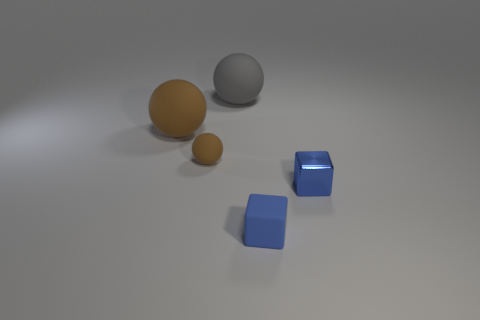Subtract all brown rubber balls. How many balls are left? 1 Subtract all brown balls. How many balls are left? 1 Add 5 large brown spheres. How many objects exist? 10 Subtract all spheres. How many objects are left? 2 Subtract 2 cubes. How many cubes are left? 0 Subtract all green spheres. Subtract all gray cylinders. How many spheres are left? 3 Subtract all gray blocks. How many brown balls are left? 2 Subtract all brown balls. Subtract all blue things. How many objects are left? 1 Add 5 balls. How many balls are left? 8 Add 1 small blocks. How many small blocks exist? 3 